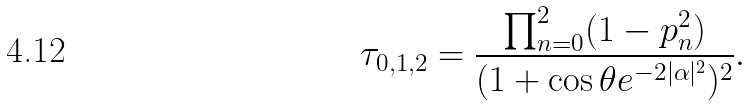Convert formula to latex. <formula><loc_0><loc_0><loc_500><loc_500>\tau _ { 0 , 1 , 2 } = \frac { \prod _ { n = 0 } ^ { 2 } ( 1 - p _ { n } ^ { 2 } ) } { ( 1 + \cos \theta e ^ { - 2 | \alpha | ^ { 2 } } ) ^ { 2 } } .</formula> 